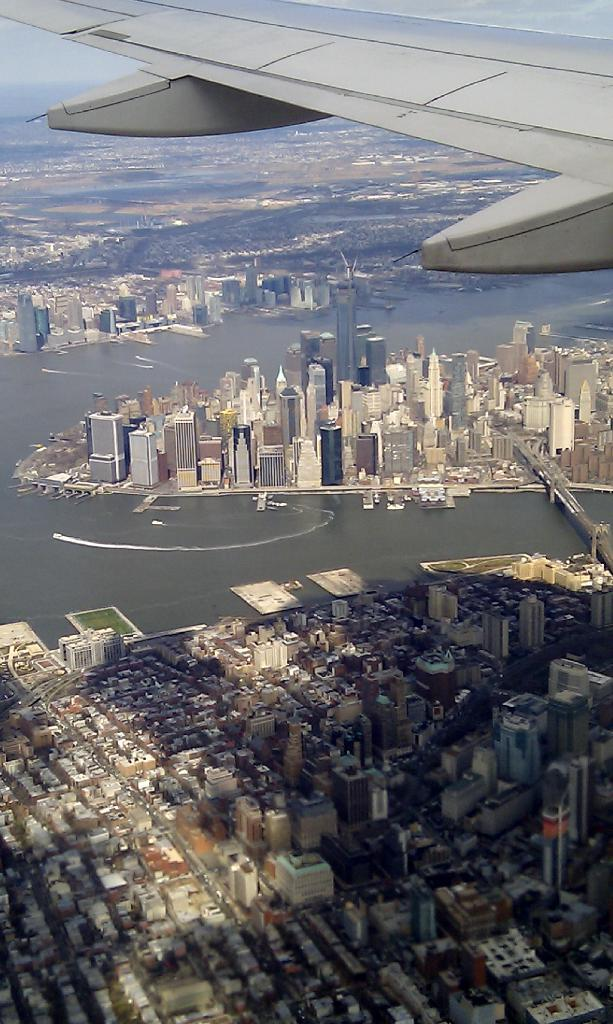What type of view is depicted in the image? The image shows an aerial view of a city. What structures can be seen in the image? There are buildings in the image. What part of an airplane can be seen in the image? There is an airplane wing visible in the image. What natural feature is present in the image? There is a river in the image. What is visible in the background of the image? The sky is visible in the image. What type of pencil is being used to draw the city in the image? There is no pencil present in the image, as it is a photograph of an actual city. 